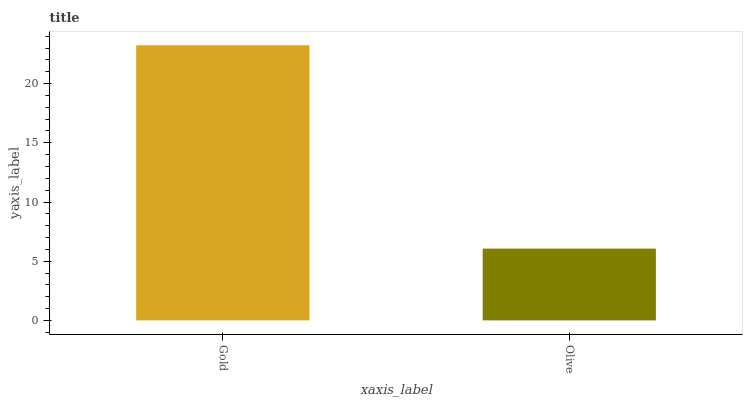Is Olive the minimum?
Answer yes or no. Yes. Is Gold the maximum?
Answer yes or no. Yes. Is Olive the maximum?
Answer yes or no. No. Is Gold greater than Olive?
Answer yes or no. Yes. Is Olive less than Gold?
Answer yes or no. Yes. Is Olive greater than Gold?
Answer yes or no. No. Is Gold less than Olive?
Answer yes or no. No. Is Gold the high median?
Answer yes or no. Yes. Is Olive the low median?
Answer yes or no. Yes. Is Olive the high median?
Answer yes or no. No. Is Gold the low median?
Answer yes or no. No. 